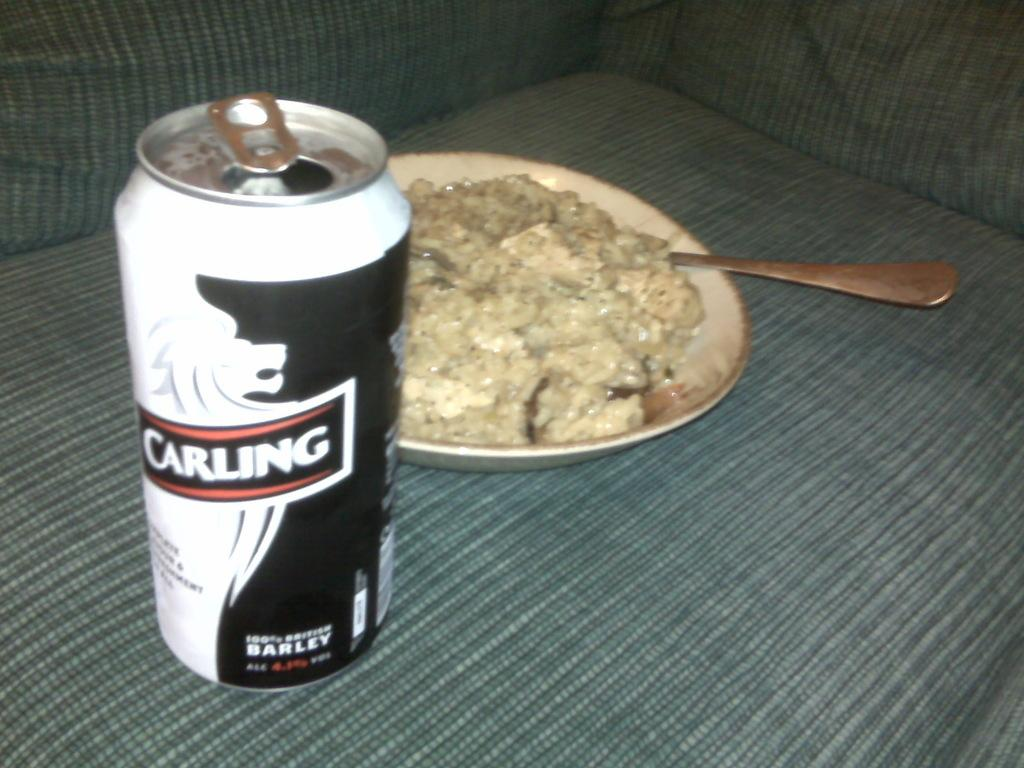What is on the plate in the image? There is a food item on a plate in the image. What utensil is present on the plate? There is a spoon on the plate in the image. Where is the tin located in the image? The tin is on the sofa in the image. What type of cork can be seen in the image? There is no cork present in the image. Can you describe the body language of the person in the image? There is no person present in the image, so it is not possible to describe their body language. 